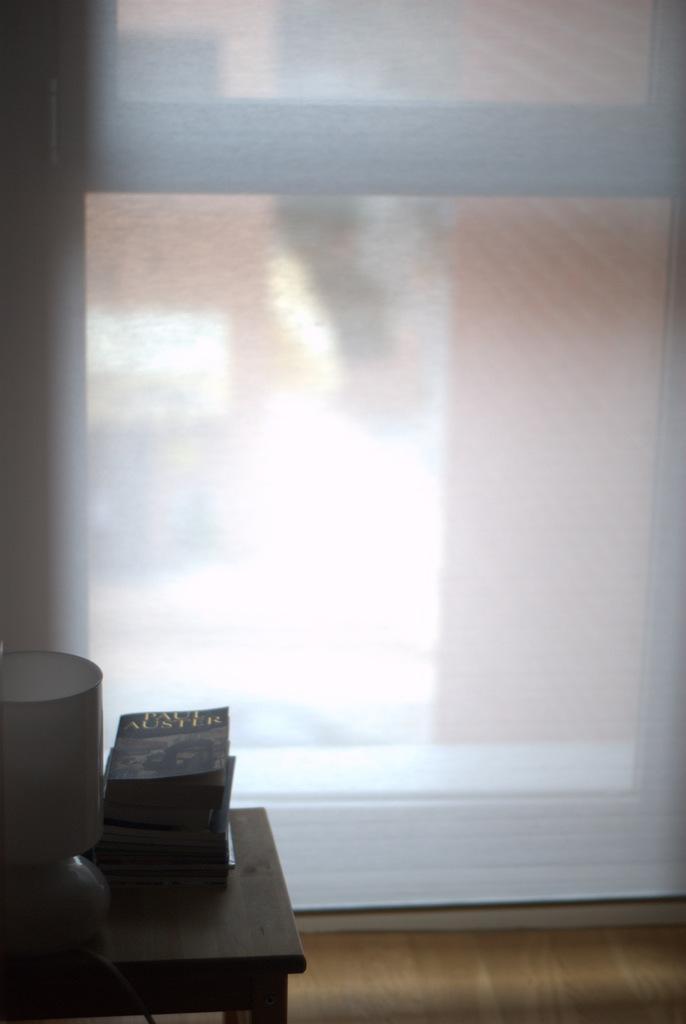In one or two sentences, can you explain what this image depicts? In the left bottom of the picture, we see a table on which books and lamp are placed. Behind that, we see a white door and this picture is clicked inside the room. 